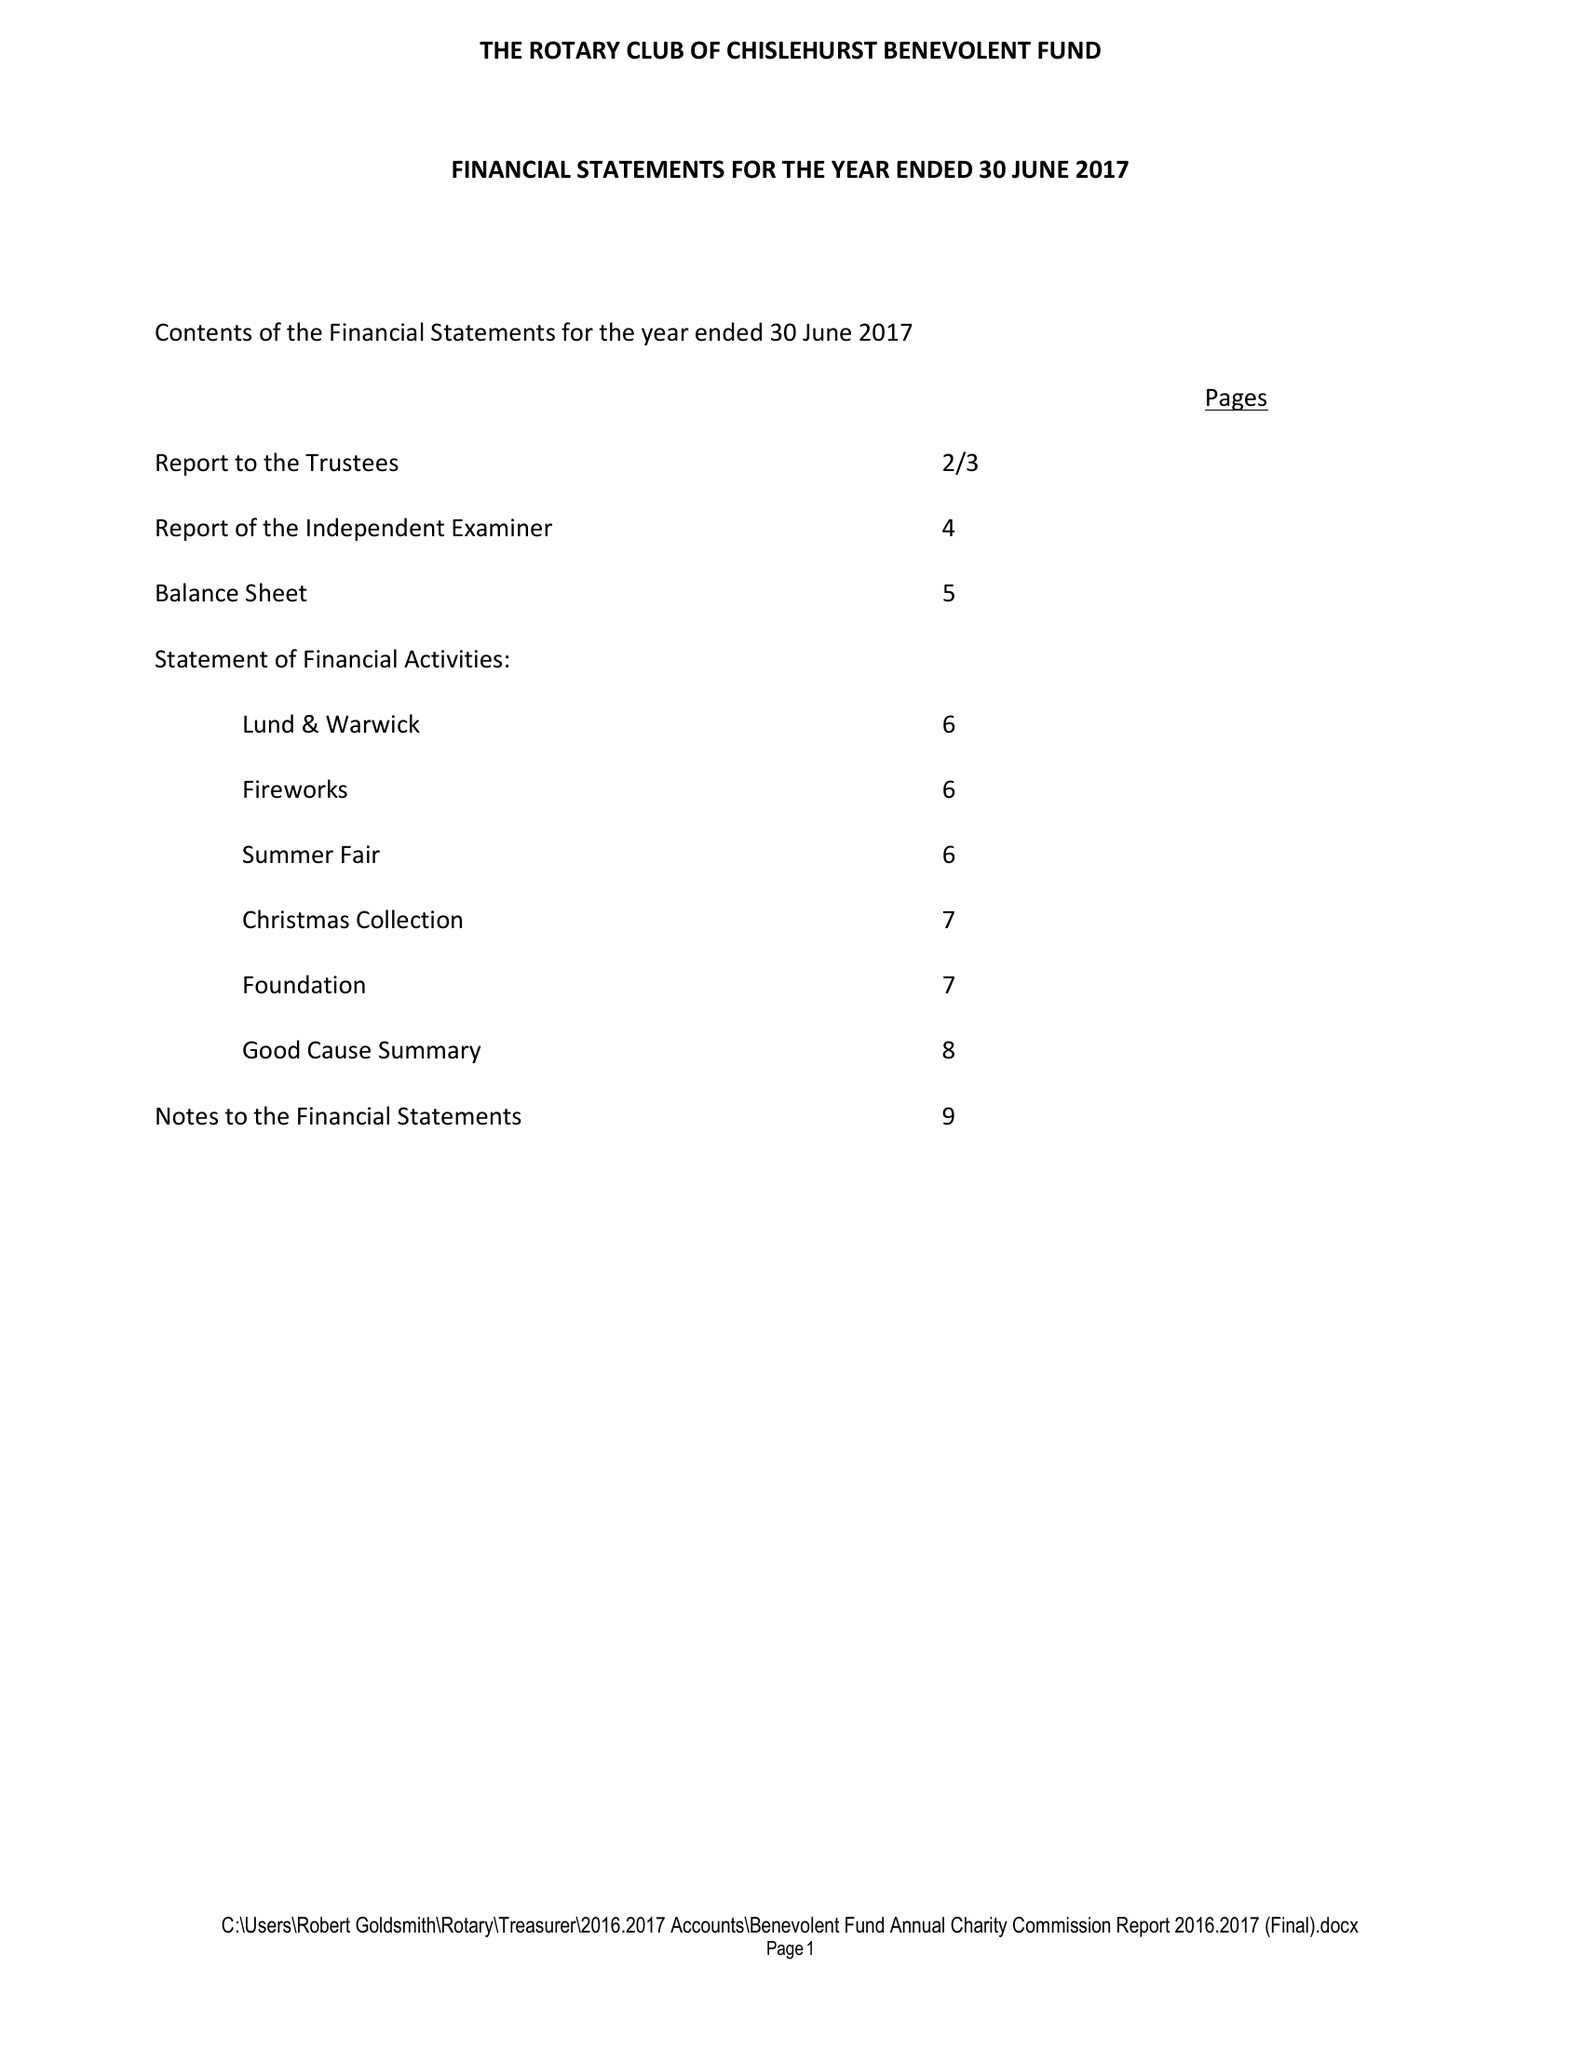What is the value for the spending_annually_in_british_pounds?
Answer the question using a single word or phrase. 47439.00 